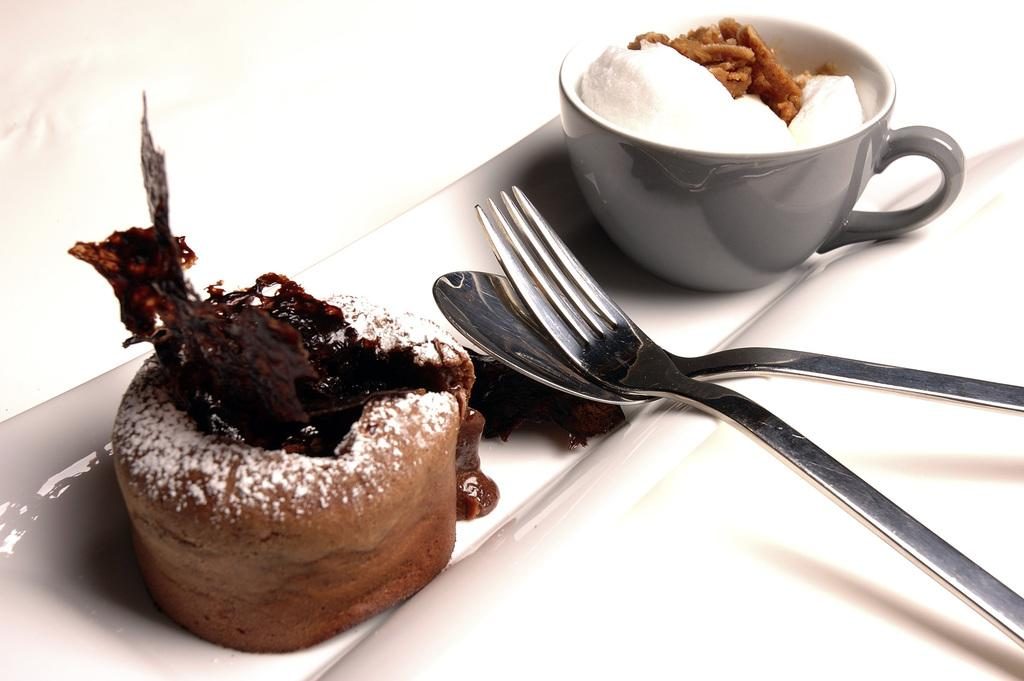What is the main food item featured in the image? There is a cake in the image. What else can be seen on the tray besides the cake? There is a cup and two spoons on the tray. How are the cake and cup arranged on the tray? Both the cake and the cup are on a tray. What type of ink is used to write on the cake in the image? There is no ink or writing on the cake in the image. How does the door in the image relate to the cake and cup? There is no door present in the image; it only features a cake, a cup, and two spoons on a tray. 